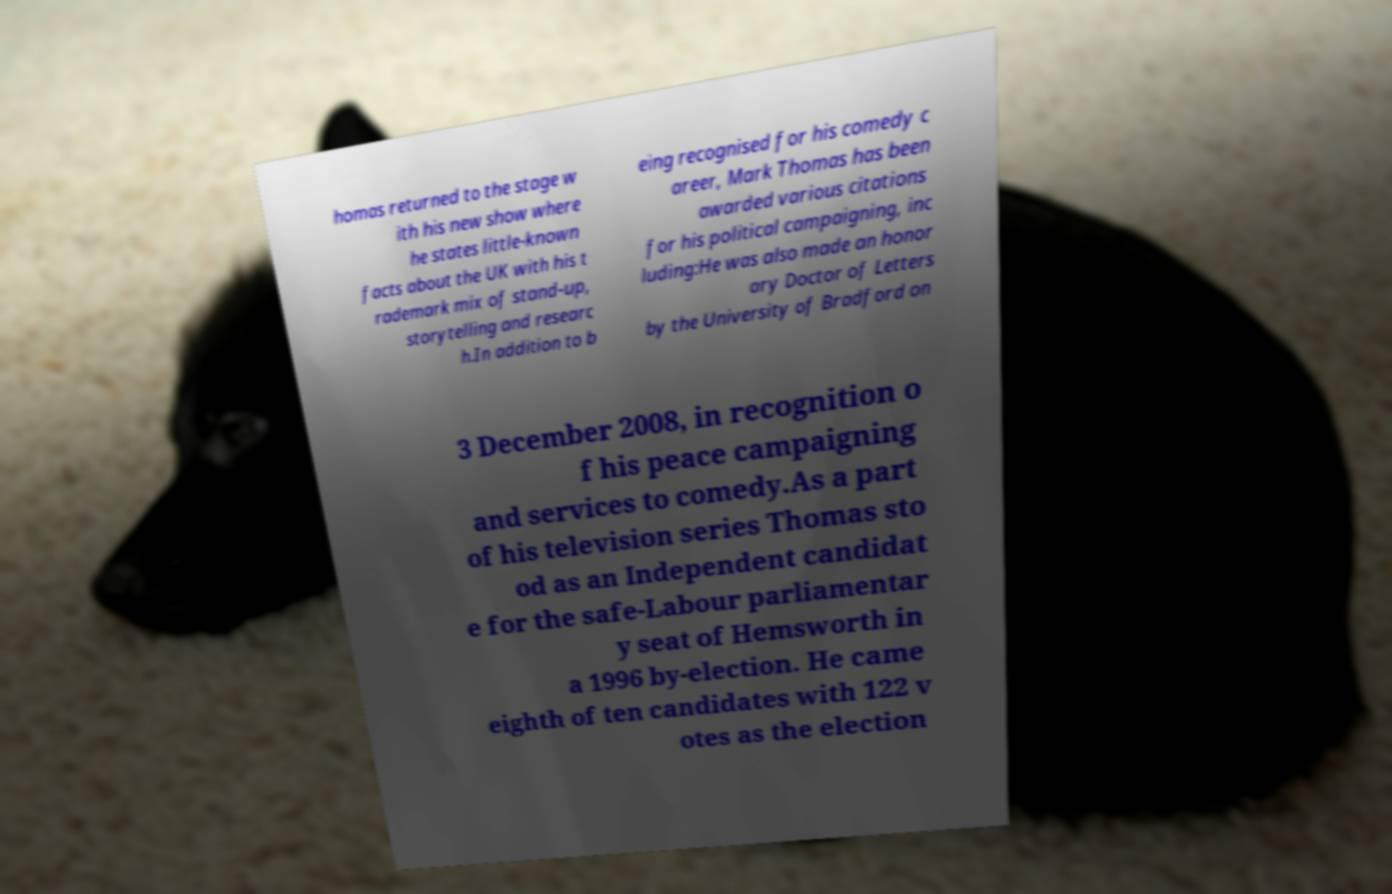Could you assist in decoding the text presented in this image and type it out clearly? homas returned to the stage w ith his new show where he states little-known facts about the UK with his t rademark mix of stand-up, storytelling and researc h.In addition to b eing recognised for his comedy c areer, Mark Thomas has been awarded various citations for his political campaigning, inc luding:He was also made an honor ary Doctor of Letters by the University of Bradford on 3 December 2008, in recognition o f his peace campaigning and services to comedy.As a part of his television series Thomas sto od as an Independent candidat e for the safe-Labour parliamentar y seat of Hemsworth in a 1996 by-election. He came eighth of ten candidates with 122 v otes as the election 